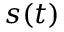<formula> <loc_0><loc_0><loc_500><loc_500>s ( t )</formula> 